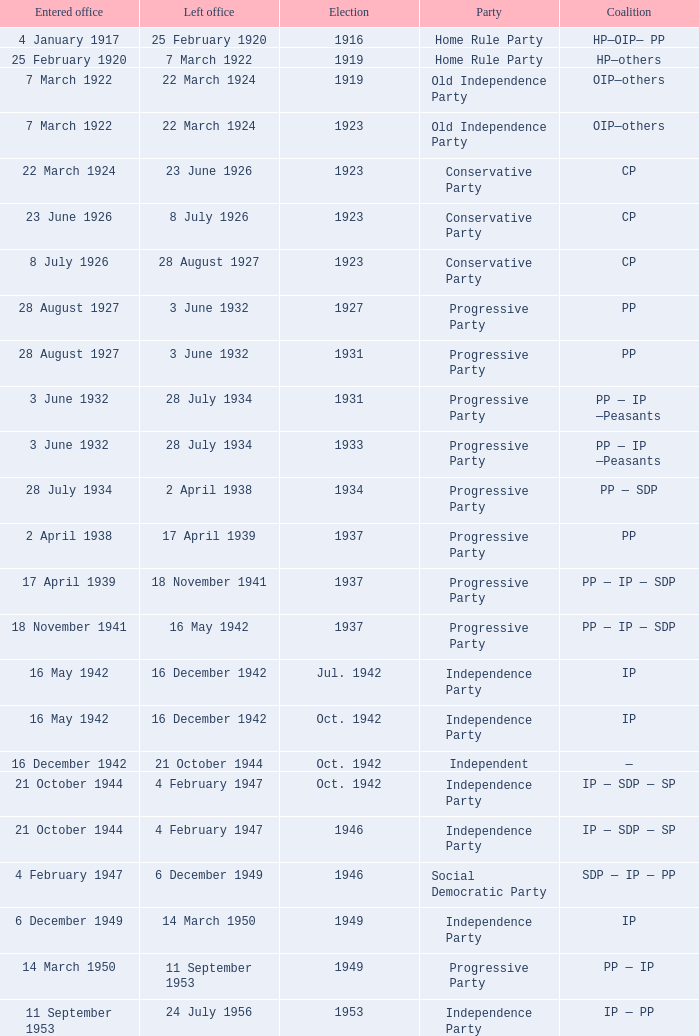When did the party elected in jun. 1959 enter office? 23 December 1958. 